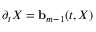Convert formula to latex. <formula><loc_0><loc_0><loc_500><loc_500>\partial _ { t } X = { b } _ { m - 1 } ( t , X )</formula> 